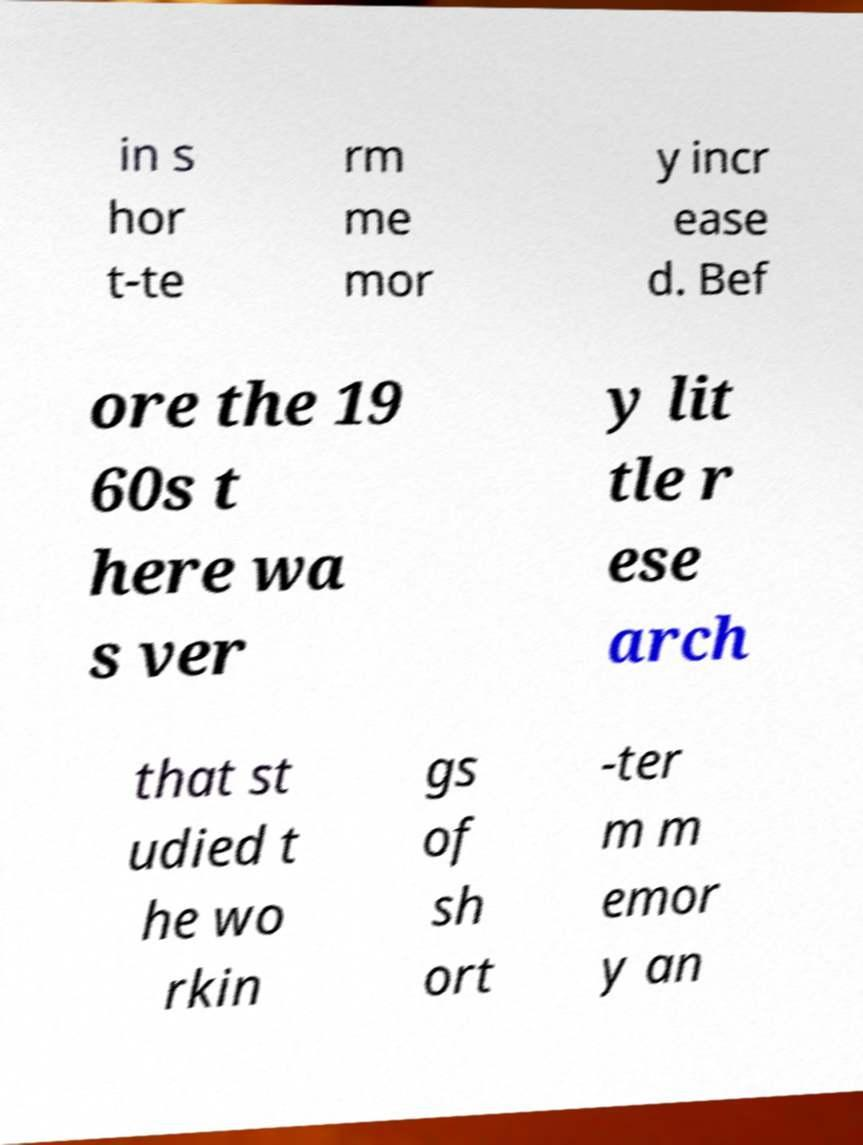What messages or text are displayed in this image? I need them in a readable, typed format. in s hor t-te rm me mor y incr ease d. Bef ore the 19 60s t here wa s ver y lit tle r ese arch that st udied t he wo rkin gs of sh ort -ter m m emor y an 